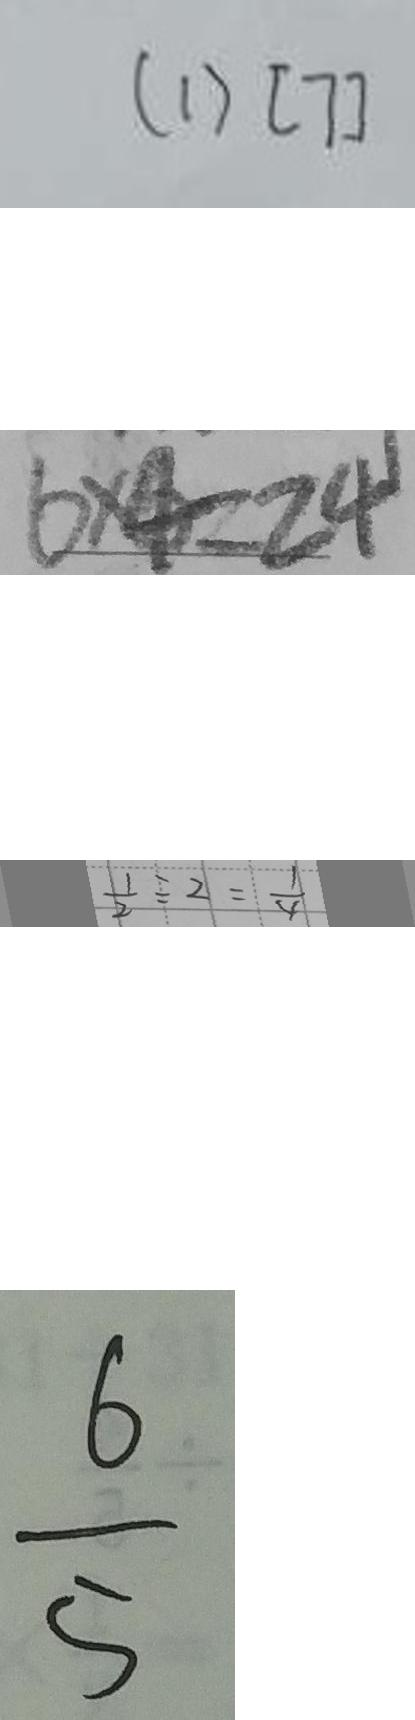<formula> <loc_0><loc_0><loc_500><loc_500>( 1 ) [ 7 ] 
 6 \times 4 = 2 4 
 \frac { 1 } { 2 } \div 2 = \frac { 1 } { 4 } 
 \frac { 6 } { 5 }</formula> 